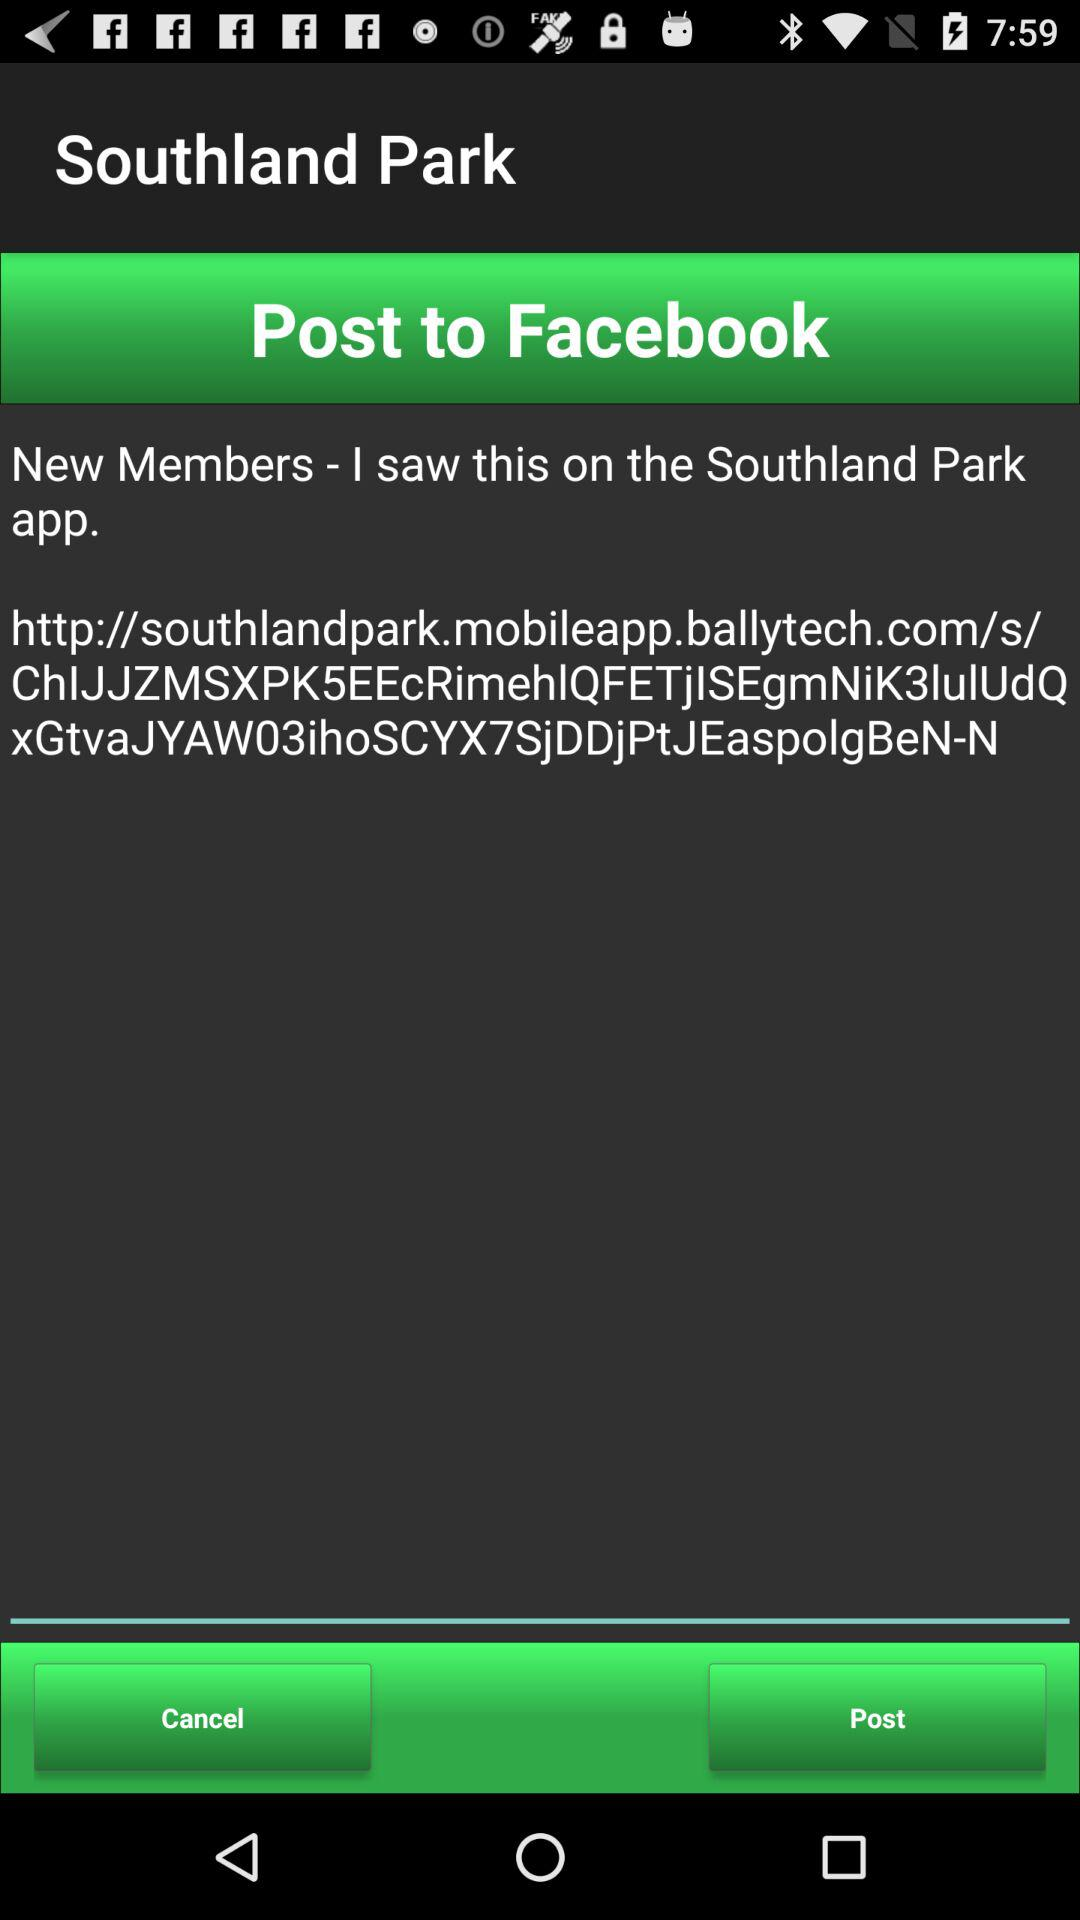Where can it be posted? It can be posted to "Facebook". 